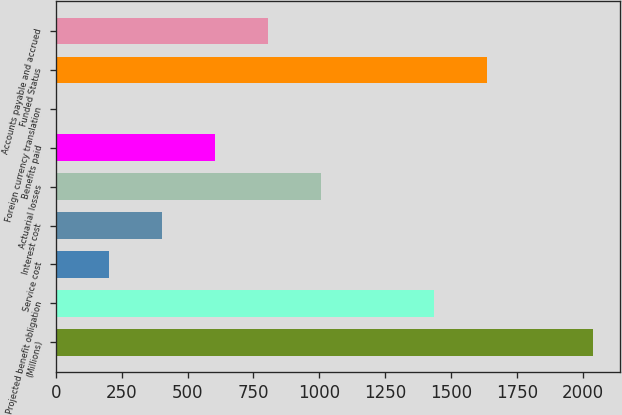Convert chart. <chart><loc_0><loc_0><loc_500><loc_500><bar_chart><fcel>(Millions)<fcel>Projected benefit obligation<fcel>Service cost<fcel>Interest cost<fcel>Actuarial losses<fcel>Benefits paid<fcel>Foreign currency translation<fcel>Funded Status<fcel>Accounts payable and accrued<nl><fcel>2038.2<fcel>1435.8<fcel>203.8<fcel>404.6<fcel>1007<fcel>605.4<fcel>3<fcel>1636.6<fcel>806.2<nl></chart> 